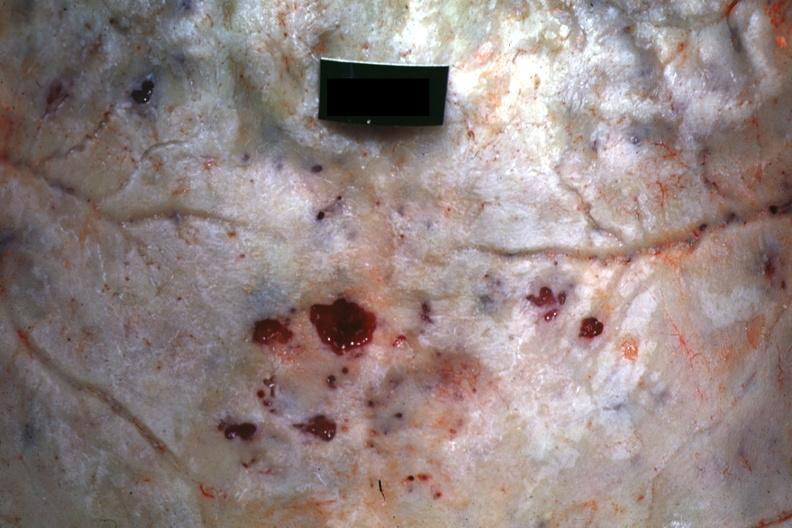s multiple myeloma present?
Answer the question using a single word or phrase. Yes 